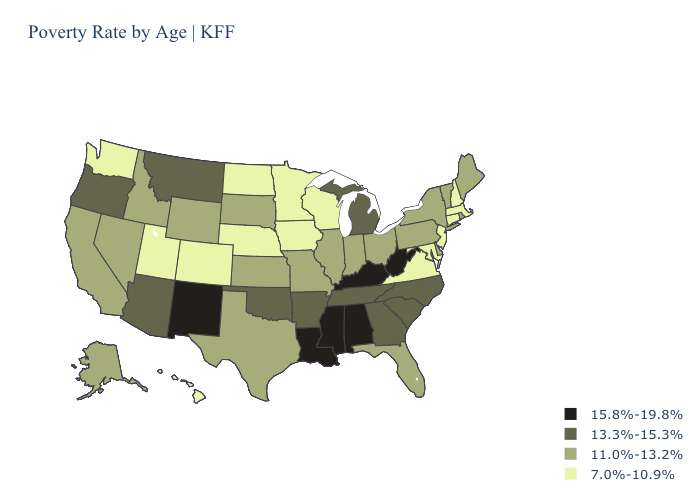What is the highest value in states that border New Mexico?
Concise answer only. 13.3%-15.3%. What is the highest value in the MidWest ?
Keep it brief. 13.3%-15.3%. Name the states that have a value in the range 7.0%-10.9%?
Be succinct. Colorado, Connecticut, Hawaii, Iowa, Maryland, Massachusetts, Minnesota, Nebraska, New Hampshire, New Jersey, North Dakota, Utah, Virginia, Washington, Wisconsin. Does Virginia have the lowest value in the South?
Short answer required. Yes. Which states have the lowest value in the USA?
Quick response, please. Colorado, Connecticut, Hawaii, Iowa, Maryland, Massachusetts, Minnesota, Nebraska, New Hampshire, New Jersey, North Dakota, Utah, Virginia, Washington, Wisconsin. Name the states that have a value in the range 7.0%-10.9%?
Be succinct. Colorado, Connecticut, Hawaii, Iowa, Maryland, Massachusetts, Minnesota, Nebraska, New Hampshire, New Jersey, North Dakota, Utah, Virginia, Washington, Wisconsin. Name the states that have a value in the range 11.0%-13.2%?
Keep it brief. Alaska, California, Delaware, Florida, Idaho, Illinois, Indiana, Kansas, Maine, Missouri, Nevada, New York, Ohio, Pennsylvania, Rhode Island, South Dakota, Texas, Vermont, Wyoming. Does New Mexico have the same value as Iowa?
Keep it brief. No. Name the states that have a value in the range 11.0%-13.2%?
Concise answer only. Alaska, California, Delaware, Florida, Idaho, Illinois, Indiana, Kansas, Maine, Missouri, Nevada, New York, Ohio, Pennsylvania, Rhode Island, South Dakota, Texas, Vermont, Wyoming. How many symbols are there in the legend?
Keep it brief. 4. What is the value of North Carolina?
Keep it brief. 13.3%-15.3%. Does the first symbol in the legend represent the smallest category?
Write a very short answer. No. What is the value of North Carolina?
Short answer required. 13.3%-15.3%. Does Connecticut have the lowest value in the USA?
Give a very brief answer. Yes. Does the first symbol in the legend represent the smallest category?
Give a very brief answer. No. 